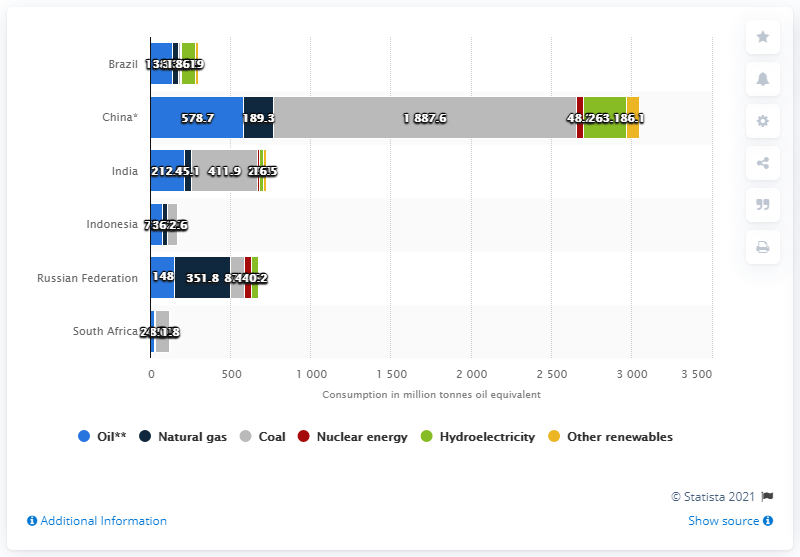List a handful of essential elements in this visual. In 2015, China consumed a total of 189.3 million metric tons of oil equivalent, which represents a significant increase from the previous year. 